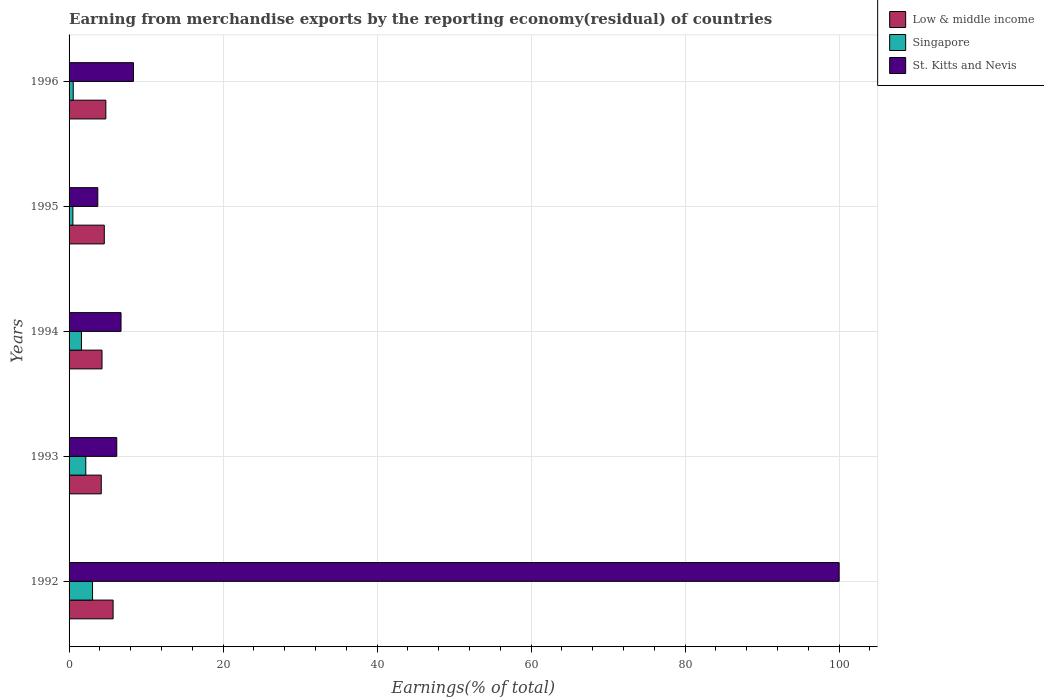How many groups of bars are there?
Your answer should be very brief. 5. Are the number of bars per tick equal to the number of legend labels?
Make the answer very short. Yes. Are the number of bars on each tick of the Y-axis equal?
Your response must be concise. Yes. How many bars are there on the 3rd tick from the bottom?
Offer a terse response. 3. In how many cases, is the number of bars for a given year not equal to the number of legend labels?
Provide a short and direct response. 0. What is the percentage of amount earned from merchandise exports in Singapore in 1992?
Provide a short and direct response. 3.05. Across all years, what is the maximum percentage of amount earned from merchandise exports in Low & middle income?
Make the answer very short. 5.72. Across all years, what is the minimum percentage of amount earned from merchandise exports in St. Kitts and Nevis?
Provide a succinct answer. 3.73. In which year was the percentage of amount earned from merchandise exports in Singapore maximum?
Provide a short and direct response. 1992. In which year was the percentage of amount earned from merchandise exports in Singapore minimum?
Make the answer very short. 1995. What is the total percentage of amount earned from merchandise exports in Singapore in the graph?
Keep it short and to the point. 7.86. What is the difference between the percentage of amount earned from merchandise exports in St. Kitts and Nevis in 1993 and that in 1996?
Provide a succinct answer. -2.17. What is the difference between the percentage of amount earned from merchandise exports in St. Kitts and Nevis in 1993 and the percentage of amount earned from merchandise exports in Low & middle income in 1994?
Ensure brevity in your answer.  1.92. What is the average percentage of amount earned from merchandise exports in Singapore per year?
Make the answer very short. 1.57. In the year 1992, what is the difference between the percentage of amount earned from merchandise exports in St. Kitts and Nevis and percentage of amount earned from merchandise exports in Low & middle income?
Your answer should be compact. 94.28. What is the ratio of the percentage of amount earned from merchandise exports in Low & middle income in 1994 to that in 1996?
Your answer should be compact. 0.9. Is the difference between the percentage of amount earned from merchandise exports in St. Kitts and Nevis in 1992 and 1996 greater than the difference between the percentage of amount earned from merchandise exports in Low & middle income in 1992 and 1996?
Give a very brief answer. Yes. What is the difference between the highest and the second highest percentage of amount earned from merchandise exports in St. Kitts and Nevis?
Offer a very short reply. 91.64. What is the difference between the highest and the lowest percentage of amount earned from merchandise exports in Singapore?
Make the answer very short. 2.55. In how many years, is the percentage of amount earned from merchandise exports in Low & middle income greater than the average percentage of amount earned from merchandise exports in Low & middle income taken over all years?
Your answer should be compact. 2. What does the 3rd bar from the bottom in 1992 represents?
Give a very brief answer. St. Kitts and Nevis. Is it the case that in every year, the sum of the percentage of amount earned from merchandise exports in Low & middle income and percentage of amount earned from merchandise exports in Singapore is greater than the percentage of amount earned from merchandise exports in St. Kitts and Nevis?
Give a very brief answer. No. How many bars are there?
Your answer should be very brief. 15. What is the difference between two consecutive major ticks on the X-axis?
Your response must be concise. 20. Are the values on the major ticks of X-axis written in scientific E-notation?
Keep it short and to the point. No. How many legend labels are there?
Your response must be concise. 3. What is the title of the graph?
Your response must be concise. Earning from merchandise exports by the reporting economy(residual) of countries. Does "Canada" appear as one of the legend labels in the graph?
Offer a terse response. No. What is the label or title of the X-axis?
Offer a very short reply. Earnings(% of total). What is the Earnings(% of total) of Low & middle income in 1992?
Your response must be concise. 5.72. What is the Earnings(% of total) of Singapore in 1992?
Ensure brevity in your answer.  3.05. What is the Earnings(% of total) in Low & middle income in 1993?
Keep it short and to the point. 4.18. What is the Earnings(% of total) of Singapore in 1993?
Keep it short and to the point. 2.17. What is the Earnings(% of total) in St. Kitts and Nevis in 1993?
Your response must be concise. 6.19. What is the Earnings(% of total) of Low & middle income in 1994?
Provide a succinct answer. 4.28. What is the Earnings(% of total) of Singapore in 1994?
Keep it short and to the point. 1.61. What is the Earnings(% of total) in St. Kitts and Nevis in 1994?
Keep it short and to the point. 6.75. What is the Earnings(% of total) of Low & middle income in 1995?
Provide a short and direct response. 4.58. What is the Earnings(% of total) in Singapore in 1995?
Provide a short and direct response. 0.5. What is the Earnings(% of total) in St. Kitts and Nevis in 1995?
Your response must be concise. 3.73. What is the Earnings(% of total) of Low & middle income in 1996?
Make the answer very short. 4.77. What is the Earnings(% of total) of Singapore in 1996?
Make the answer very short. 0.54. What is the Earnings(% of total) of St. Kitts and Nevis in 1996?
Offer a very short reply. 8.36. Across all years, what is the maximum Earnings(% of total) in Low & middle income?
Your response must be concise. 5.72. Across all years, what is the maximum Earnings(% of total) in Singapore?
Give a very brief answer. 3.05. Across all years, what is the minimum Earnings(% of total) of Low & middle income?
Offer a very short reply. 4.18. Across all years, what is the minimum Earnings(% of total) in Singapore?
Your answer should be compact. 0.5. Across all years, what is the minimum Earnings(% of total) of St. Kitts and Nevis?
Offer a very short reply. 3.73. What is the total Earnings(% of total) of Low & middle income in the graph?
Your answer should be compact. 23.53. What is the total Earnings(% of total) in Singapore in the graph?
Your answer should be compact. 7.86. What is the total Earnings(% of total) in St. Kitts and Nevis in the graph?
Ensure brevity in your answer.  125.03. What is the difference between the Earnings(% of total) in Low & middle income in 1992 and that in 1993?
Give a very brief answer. 1.54. What is the difference between the Earnings(% of total) in Singapore in 1992 and that in 1993?
Offer a terse response. 0.88. What is the difference between the Earnings(% of total) of St. Kitts and Nevis in 1992 and that in 1993?
Your answer should be very brief. 93.81. What is the difference between the Earnings(% of total) in Low & middle income in 1992 and that in 1994?
Provide a short and direct response. 1.44. What is the difference between the Earnings(% of total) in Singapore in 1992 and that in 1994?
Offer a terse response. 1.44. What is the difference between the Earnings(% of total) of St. Kitts and Nevis in 1992 and that in 1994?
Offer a terse response. 93.25. What is the difference between the Earnings(% of total) of Singapore in 1992 and that in 1995?
Offer a terse response. 2.55. What is the difference between the Earnings(% of total) of St. Kitts and Nevis in 1992 and that in 1995?
Offer a very short reply. 96.27. What is the difference between the Earnings(% of total) of Low & middle income in 1992 and that in 1996?
Ensure brevity in your answer.  0.94. What is the difference between the Earnings(% of total) of Singapore in 1992 and that in 1996?
Provide a short and direct response. 2.51. What is the difference between the Earnings(% of total) of St. Kitts and Nevis in 1992 and that in 1996?
Offer a terse response. 91.64. What is the difference between the Earnings(% of total) in Low & middle income in 1993 and that in 1994?
Give a very brief answer. -0.1. What is the difference between the Earnings(% of total) of Singapore in 1993 and that in 1994?
Ensure brevity in your answer.  0.56. What is the difference between the Earnings(% of total) in St. Kitts and Nevis in 1993 and that in 1994?
Provide a succinct answer. -0.55. What is the difference between the Earnings(% of total) in Low & middle income in 1993 and that in 1995?
Provide a short and direct response. -0.4. What is the difference between the Earnings(% of total) of Singapore in 1993 and that in 1995?
Keep it short and to the point. 1.67. What is the difference between the Earnings(% of total) of St. Kitts and Nevis in 1993 and that in 1995?
Offer a very short reply. 2.46. What is the difference between the Earnings(% of total) in Low & middle income in 1993 and that in 1996?
Offer a very short reply. -0.59. What is the difference between the Earnings(% of total) in Singapore in 1993 and that in 1996?
Provide a short and direct response. 1.63. What is the difference between the Earnings(% of total) in St. Kitts and Nevis in 1993 and that in 1996?
Ensure brevity in your answer.  -2.17. What is the difference between the Earnings(% of total) of Low & middle income in 1994 and that in 1995?
Keep it short and to the point. -0.3. What is the difference between the Earnings(% of total) of Singapore in 1994 and that in 1995?
Keep it short and to the point. 1.11. What is the difference between the Earnings(% of total) in St. Kitts and Nevis in 1994 and that in 1995?
Your answer should be very brief. 3.02. What is the difference between the Earnings(% of total) in Low & middle income in 1994 and that in 1996?
Keep it short and to the point. -0.5. What is the difference between the Earnings(% of total) of Singapore in 1994 and that in 1996?
Ensure brevity in your answer.  1.06. What is the difference between the Earnings(% of total) of St. Kitts and Nevis in 1994 and that in 1996?
Provide a succinct answer. -1.61. What is the difference between the Earnings(% of total) of Low & middle income in 1995 and that in 1996?
Ensure brevity in your answer.  -0.2. What is the difference between the Earnings(% of total) of Singapore in 1995 and that in 1996?
Provide a succinct answer. -0.04. What is the difference between the Earnings(% of total) of St. Kitts and Nevis in 1995 and that in 1996?
Offer a terse response. -4.63. What is the difference between the Earnings(% of total) in Low & middle income in 1992 and the Earnings(% of total) in Singapore in 1993?
Ensure brevity in your answer.  3.55. What is the difference between the Earnings(% of total) in Low & middle income in 1992 and the Earnings(% of total) in St. Kitts and Nevis in 1993?
Offer a very short reply. -0.48. What is the difference between the Earnings(% of total) in Singapore in 1992 and the Earnings(% of total) in St. Kitts and Nevis in 1993?
Provide a short and direct response. -3.15. What is the difference between the Earnings(% of total) of Low & middle income in 1992 and the Earnings(% of total) of Singapore in 1994?
Keep it short and to the point. 4.11. What is the difference between the Earnings(% of total) in Low & middle income in 1992 and the Earnings(% of total) in St. Kitts and Nevis in 1994?
Your response must be concise. -1.03. What is the difference between the Earnings(% of total) of Singapore in 1992 and the Earnings(% of total) of St. Kitts and Nevis in 1994?
Make the answer very short. -3.7. What is the difference between the Earnings(% of total) of Low & middle income in 1992 and the Earnings(% of total) of Singapore in 1995?
Your response must be concise. 5.22. What is the difference between the Earnings(% of total) in Low & middle income in 1992 and the Earnings(% of total) in St. Kitts and Nevis in 1995?
Give a very brief answer. 1.99. What is the difference between the Earnings(% of total) of Singapore in 1992 and the Earnings(% of total) of St. Kitts and Nevis in 1995?
Offer a terse response. -0.68. What is the difference between the Earnings(% of total) of Low & middle income in 1992 and the Earnings(% of total) of Singapore in 1996?
Make the answer very short. 5.18. What is the difference between the Earnings(% of total) of Low & middle income in 1992 and the Earnings(% of total) of St. Kitts and Nevis in 1996?
Your answer should be very brief. -2.64. What is the difference between the Earnings(% of total) in Singapore in 1992 and the Earnings(% of total) in St. Kitts and Nevis in 1996?
Your response must be concise. -5.31. What is the difference between the Earnings(% of total) of Low & middle income in 1993 and the Earnings(% of total) of Singapore in 1994?
Offer a very short reply. 2.57. What is the difference between the Earnings(% of total) in Low & middle income in 1993 and the Earnings(% of total) in St. Kitts and Nevis in 1994?
Your answer should be very brief. -2.57. What is the difference between the Earnings(% of total) of Singapore in 1993 and the Earnings(% of total) of St. Kitts and Nevis in 1994?
Give a very brief answer. -4.58. What is the difference between the Earnings(% of total) of Low & middle income in 1993 and the Earnings(% of total) of Singapore in 1995?
Offer a very short reply. 3.68. What is the difference between the Earnings(% of total) of Low & middle income in 1993 and the Earnings(% of total) of St. Kitts and Nevis in 1995?
Your answer should be compact. 0.45. What is the difference between the Earnings(% of total) in Singapore in 1993 and the Earnings(% of total) in St. Kitts and Nevis in 1995?
Provide a succinct answer. -1.56. What is the difference between the Earnings(% of total) in Low & middle income in 1993 and the Earnings(% of total) in Singapore in 1996?
Offer a very short reply. 3.64. What is the difference between the Earnings(% of total) in Low & middle income in 1993 and the Earnings(% of total) in St. Kitts and Nevis in 1996?
Keep it short and to the point. -4.18. What is the difference between the Earnings(% of total) in Singapore in 1993 and the Earnings(% of total) in St. Kitts and Nevis in 1996?
Keep it short and to the point. -6.19. What is the difference between the Earnings(% of total) of Low & middle income in 1994 and the Earnings(% of total) of Singapore in 1995?
Offer a very short reply. 3.78. What is the difference between the Earnings(% of total) in Low & middle income in 1994 and the Earnings(% of total) in St. Kitts and Nevis in 1995?
Keep it short and to the point. 0.55. What is the difference between the Earnings(% of total) in Singapore in 1994 and the Earnings(% of total) in St. Kitts and Nevis in 1995?
Offer a terse response. -2.12. What is the difference between the Earnings(% of total) in Low & middle income in 1994 and the Earnings(% of total) in Singapore in 1996?
Your response must be concise. 3.74. What is the difference between the Earnings(% of total) of Low & middle income in 1994 and the Earnings(% of total) of St. Kitts and Nevis in 1996?
Your answer should be compact. -4.08. What is the difference between the Earnings(% of total) in Singapore in 1994 and the Earnings(% of total) in St. Kitts and Nevis in 1996?
Make the answer very short. -6.75. What is the difference between the Earnings(% of total) in Low & middle income in 1995 and the Earnings(% of total) in Singapore in 1996?
Make the answer very short. 4.03. What is the difference between the Earnings(% of total) in Low & middle income in 1995 and the Earnings(% of total) in St. Kitts and Nevis in 1996?
Keep it short and to the point. -3.78. What is the difference between the Earnings(% of total) of Singapore in 1995 and the Earnings(% of total) of St. Kitts and Nevis in 1996?
Your response must be concise. -7.86. What is the average Earnings(% of total) in Low & middle income per year?
Make the answer very short. 4.71. What is the average Earnings(% of total) in Singapore per year?
Your answer should be very brief. 1.57. What is the average Earnings(% of total) in St. Kitts and Nevis per year?
Provide a succinct answer. 25.01. In the year 1992, what is the difference between the Earnings(% of total) of Low & middle income and Earnings(% of total) of Singapore?
Your response must be concise. 2.67. In the year 1992, what is the difference between the Earnings(% of total) in Low & middle income and Earnings(% of total) in St. Kitts and Nevis?
Offer a terse response. -94.28. In the year 1992, what is the difference between the Earnings(% of total) of Singapore and Earnings(% of total) of St. Kitts and Nevis?
Provide a short and direct response. -96.95. In the year 1993, what is the difference between the Earnings(% of total) in Low & middle income and Earnings(% of total) in Singapore?
Make the answer very short. 2.01. In the year 1993, what is the difference between the Earnings(% of total) in Low & middle income and Earnings(% of total) in St. Kitts and Nevis?
Make the answer very short. -2.01. In the year 1993, what is the difference between the Earnings(% of total) of Singapore and Earnings(% of total) of St. Kitts and Nevis?
Your response must be concise. -4.02. In the year 1994, what is the difference between the Earnings(% of total) in Low & middle income and Earnings(% of total) in Singapore?
Keep it short and to the point. 2.67. In the year 1994, what is the difference between the Earnings(% of total) in Low & middle income and Earnings(% of total) in St. Kitts and Nevis?
Provide a short and direct response. -2.47. In the year 1994, what is the difference between the Earnings(% of total) of Singapore and Earnings(% of total) of St. Kitts and Nevis?
Give a very brief answer. -5.14. In the year 1995, what is the difference between the Earnings(% of total) in Low & middle income and Earnings(% of total) in Singapore?
Keep it short and to the point. 4.08. In the year 1995, what is the difference between the Earnings(% of total) of Low & middle income and Earnings(% of total) of St. Kitts and Nevis?
Your answer should be compact. 0.84. In the year 1995, what is the difference between the Earnings(% of total) of Singapore and Earnings(% of total) of St. Kitts and Nevis?
Keep it short and to the point. -3.23. In the year 1996, what is the difference between the Earnings(% of total) of Low & middle income and Earnings(% of total) of Singapore?
Your answer should be compact. 4.23. In the year 1996, what is the difference between the Earnings(% of total) in Low & middle income and Earnings(% of total) in St. Kitts and Nevis?
Ensure brevity in your answer.  -3.59. In the year 1996, what is the difference between the Earnings(% of total) of Singapore and Earnings(% of total) of St. Kitts and Nevis?
Ensure brevity in your answer.  -7.82. What is the ratio of the Earnings(% of total) of Low & middle income in 1992 to that in 1993?
Your answer should be very brief. 1.37. What is the ratio of the Earnings(% of total) of Singapore in 1992 to that in 1993?
Give a very brief answer. 1.4. What is the ratio of the Earnings(% of total) of St. Kitts and Nevis in 1992 to that in 1993?
Give a very brief answer. 16.15. What is the ratio of the Earnings(% of total) of Low & middle income in 1992 to that in 1994?
Your answer should be very brief. 1.34. What is the ratio of the Earnings(% of total) in Singapore in 1992 to that in 1994?
Give a very brief answer. 1.9. What is the ratio of the Earnings(% of total) of St. Kitts and Nevis in 1992 to that in 1994?
Your answer should be very brief. 14.82. What is the ratio of the Earnings(% of total) of Low & middle income in 1992 to that in 1995?
Give a very brief answer. 1.25. What is the ratio of the Earnings(% of total) of Singapore in 1992 to that in 1995?
Give a very brief answer. 6.13. What is the ratio of the Earnings(% of total) of St. Kitts and Nevis in 1992 to that in 1995?
Provide a succinct answer. 26.81. What is the ratio of the Earnings(% of total) in Low & middle income in 1992 to that in 1996?
Your answer should be compact. 1.2. What is the ratio of the Earnings(% of total) in Singapore in 1992 to that in 1996?
Keep it short and to the point. 5.63. What is the ratio of the Earnings(% of total) of St. Kitts and Nevis in 1992 to that in 1996?
Provide a short and direct response. 11.96. What is the ratio of the Earnings(% of total) in Singapore in 1993 to that in 1994?
Give a very brief answer. 1.35. What is the ratio of the Earnings(% of total) of St. Kitts and Nevis in 1993 to that in 1994?
Provide a short and direct response. 0.92. What is the ratio of the Earnings(% of total) in Low & middle income in 1993 to that in 1995?
Your response must be concise. 0.91. What is the ratio of the Earnings(% of total) in Singapore in 1993 to that in 1995?
Offer a terse response. 4.37. What is the ratio of the Earnings(% of total) of St. Kitts and Nevis in 1993 to that in 1995?
Offer a very short reply. 1.66. What is the ratio of the Earnings(% of total) in Low & middle income in 1993 to that in 1996?
Provide a short and direct response. 0.88. What is the ratio of the Earnings(% of total) in Singapore in 1993 to that in 1996?
Ensure brevity in your answer.  4.01. What is the ratio of the Earnings(% of total) of St. Kitts and Nevis in 1993 to that in 1996?
Your answer should be very brief. 0.74. What is the ratio of the Earnings(% of total) in Low & middle income in 1994 to that in 1995?
Your answer should be very brief. 0.94. What is the ratio of the Earnings(% of total) of Singapore in 1994 to that in 1995?
Your response must be concise. 3.23. What is the ratio of the Earnings(% of total) of St. Kitts and Nevis in 1994 to that in 1995?
Give a very brief answer. 1.81. What is the ratio of the Earnings(% of total) of Low & middle income in 1994 to that in 1996?
Provide a short and direct response. 0.9. What is the ratio of the Earnings(% of total) in Singapore in 1994 to that in 1996?
Your answer should be very brief. 2.97. What is the ratio of the Earnings(% of total) in St. Kitts and Nevis in 1994 to that in 1996?
Provide a short and direct response. 0.81. What is the ratio of the Earnings(% of total) in Low & middle income in 1995 to that in 1996?
Provide a short and direct response. 0.96. What is the ratio of the Earnings(% of total) in Singapore in 1995 to that in 1996?
Provide a succinct answer. 0.92. What is the ratio of the Earnings(% of total) in St. Kitts and Nevis in 1995 to that in 1996?
Keep it short and to the point. 0.45. What is the difference between the highest and the second highest Earnings(% of total) of Low & middle income?
Ensure brevity in your answer.  0.94. What is the difference between the highest and the second highest Earnings(% of total) in Singapore?
Give a very brief answer. 0.88. What is the difference between the highest and the second highest Earnings(% of total) of St. Kitts and Nevis?
Make the answer very short. 91.64. What is the difference between the highest and the lowest Earnings(% of total) of Low & middle income?
Your answer should be compact. 1.54. What is the difference between the highest and the lowest Earnings(% of total) in Singapore?
Offer a very short reply. 2.55. What is the difference between the highest and the lowest Earnings(% of total) of St. Kitts and Nevis?
Ensure brevity in your answer.  96.27. 